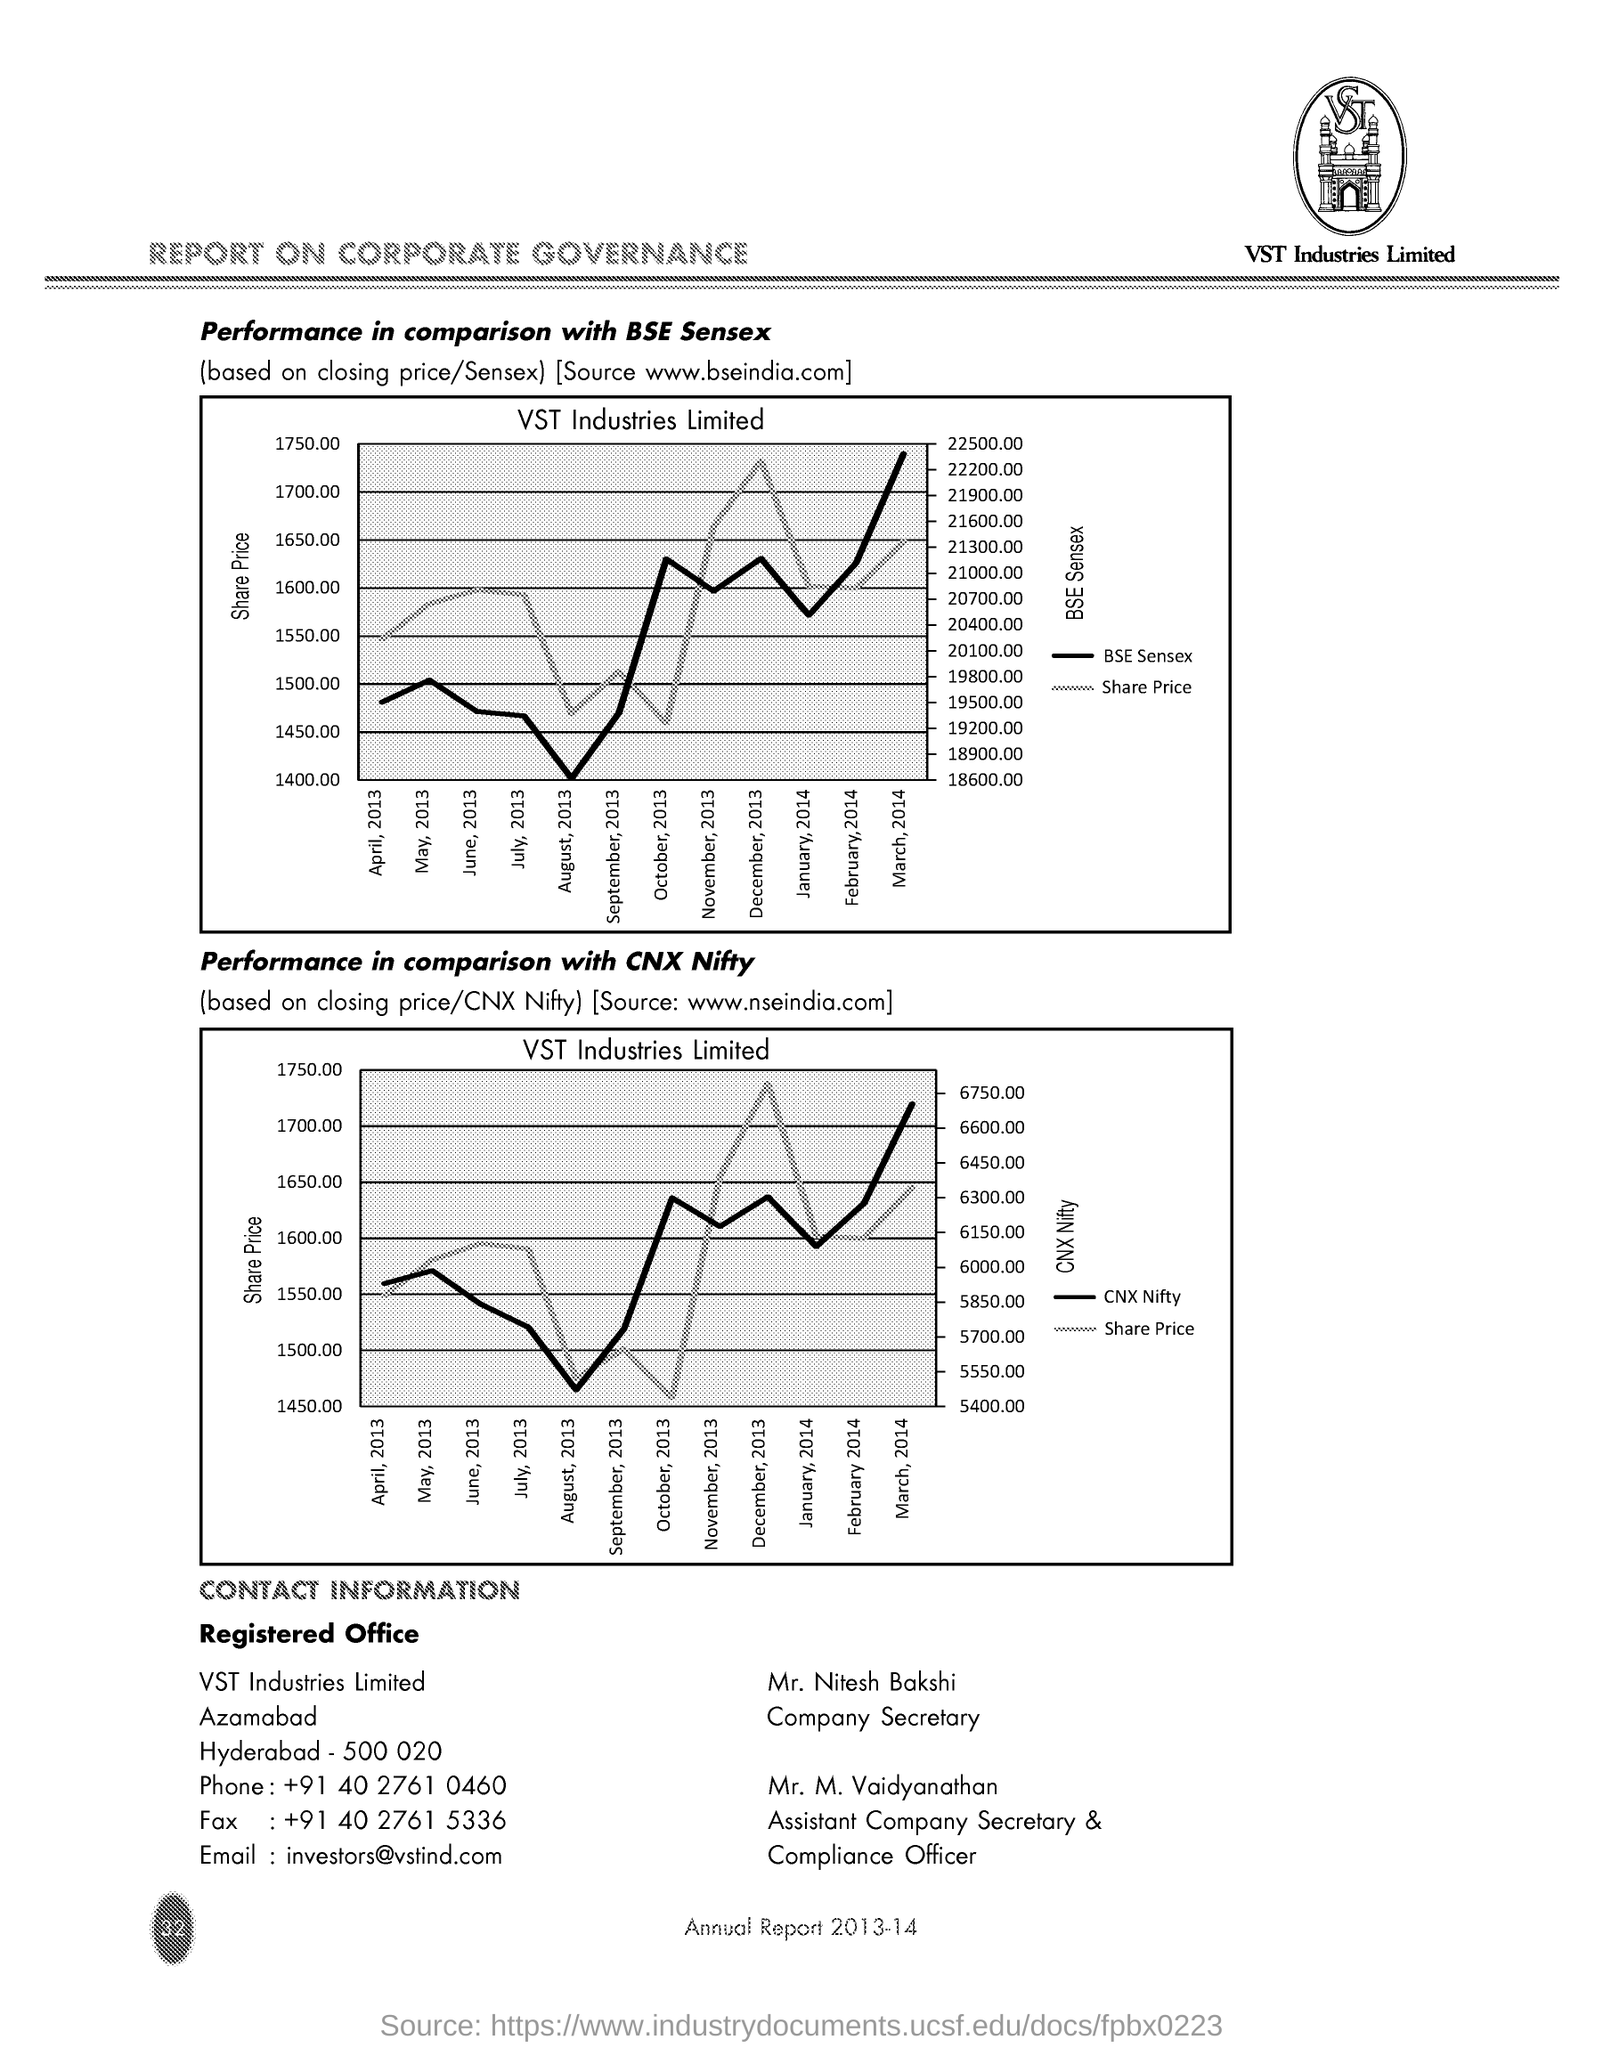Who is the Company Secretary?
Your answer should be very brief. Mr. Nitesh Bakshi. What is the Phone?
Make the answer very short. +91 40 2761 0460. What is the Fax?
Provide a succinct answer. +91 40 2761 5336. What is the email?
Offer a terse response. Investors@vstind.com. Who is the Assistant Company Secretary & Compliance Officer?
Ensure brevity in your answer.  Mr. M Vaidyanathan. 